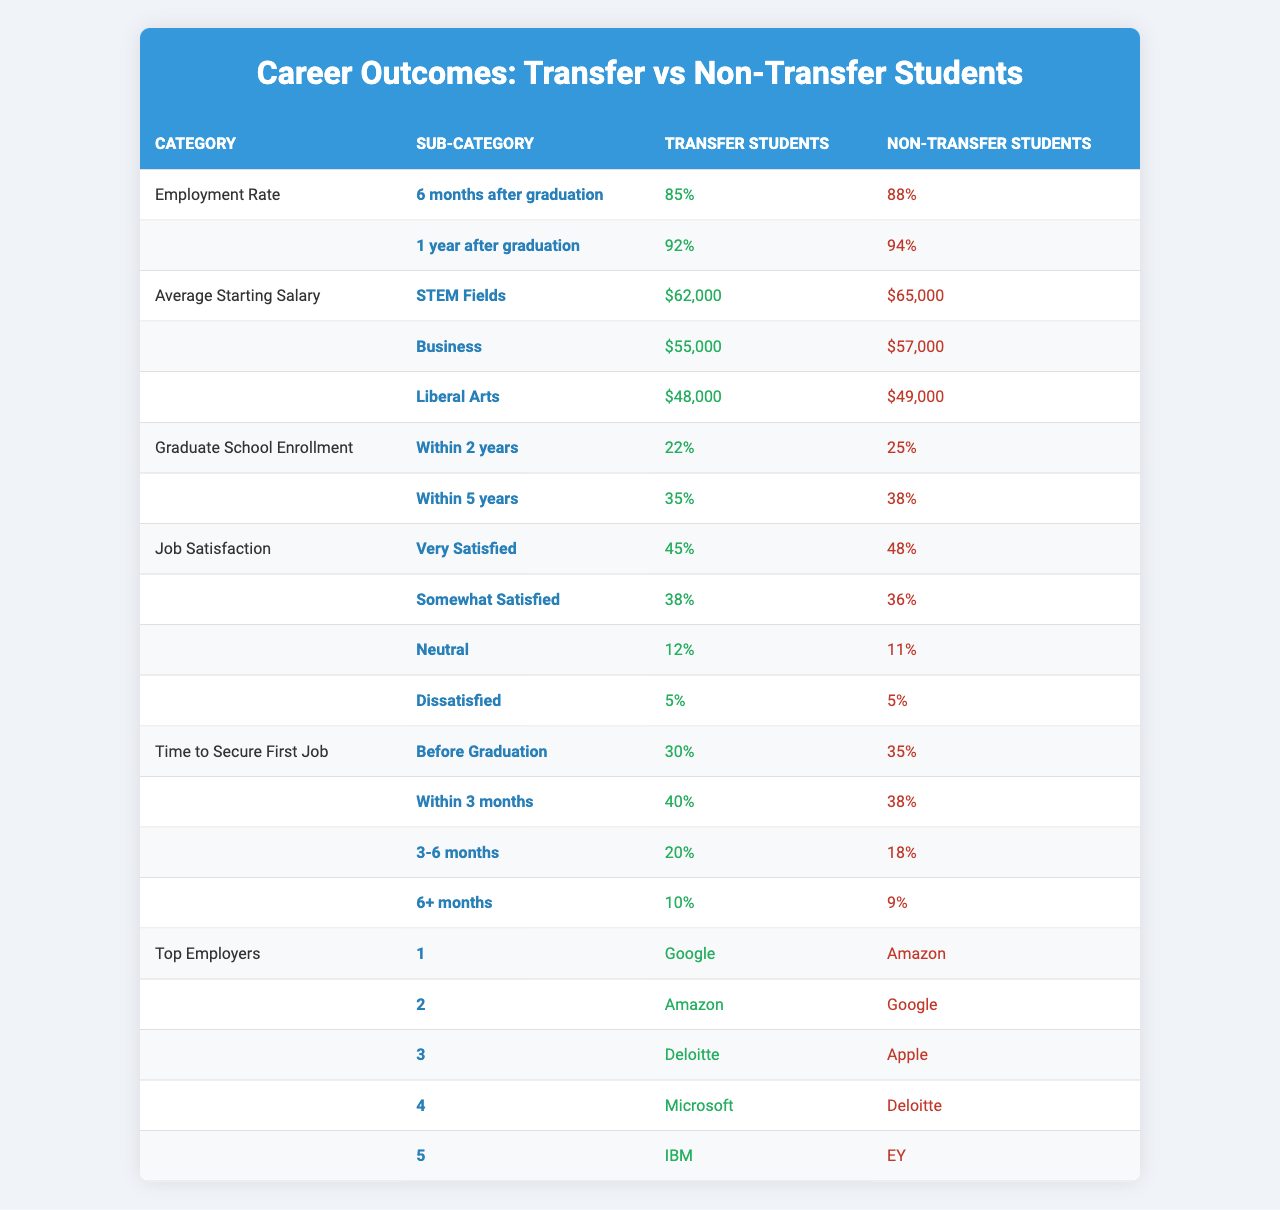What is the employment rate for transfer students 6 months after graduation? According to the table, the employment rate for transfer students is listed as 85% for six months after graduation.
Answer: 85% What is the average starting salary for non-transfer students in Business? The table shows that the average starting salary for non-transfer students in Business is $57,000.
Answer: $57,000 Which group has a higher percentage of individuals satisfied with their jobs, transfer or non-transfer students? From the table, 48% of non-transfer students reported being very satisfied compared to 45% of transfer students, indicating non-transfer students have a higher percentage.
Answer: Non-transfer students What is the difference in employment rates 1 year after graduation between transfer and non-transfer students? The employment rate for non-transfer students is 94% and for transfer students is 92%. The difference is calculated by subtracting the transfer rate from the non-transfer rate: 94% - 92% = 2%.
Answer: 2% What percentage of transfer students enroll in graduate school within 2 years compared to non-transfer students? Transfer students have a 22% enrollment rate within 2 years, while non-transfer students have a 25% enrollment rate. The difference indicates that non-transfer students have a slightly higher rate by 3%.
Answer: 3% What is the time frame in which most transfer students secure their first job according to the table? The table indicates that 40% of transfer students secure their first job within 3 months, which is the highest percentage compared to other time frames.
Answer: Within 3 months Which category shows no difference in dissatisfaction rates between transfer and non-transfer students? The "Job Satisfaction" category shows that both transfer and non-transfer students have a dissatisfaction rate of 5%. Therefore, there is no difference in this rate.
Answer: Job Satisfaction How do the top employers differ for transfer and non-transfer students? The table lists different top employers for both groups: transfer students' top employer is Google, while for non-transfer students, it is Amazon. Analyzing the entire list shows differences in rankings but also some overlap.
Answer: They differ What is the average starting salary for transfer students across all fields? To find the average starting salary for transfer students, add the salaries in the categories: ($62,000 + $55,000 + $48,000) = $165,000, then divide by 3 (the number of fields), resulting in an average of $55,000.
Answer: $55,000 Are transfer students more likely to enroll in graduate school within 5 years compared to non-transfer students? The table states that 35% of transfer students enroll in graduate school within 5 years, while 38% of non-transfer students do the same. Therefore, transfer students are less likely to enroll within that time frame.
Answer: No 